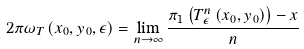Convert formula to latex. <formula><loc_0><loc_0><loc_500><loc_500>2 \pi \omega _ { T } \left ( x _ { 0 } , y _ { 0 } , \epsilon \right ) = \lim _ { n \rightarrow \infty } \frac { \pi _ { 1 } \left ( T _ { \epsilon } ^ { n } \left ( x _ { 0 } , y _ { 0 } \right ) \right ) - x } { n }</formula> 